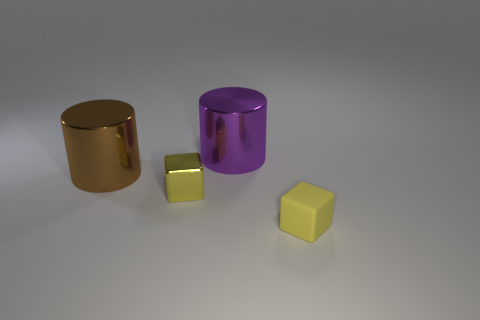How would you describe the texture of the objects in this image? The objects in the image appear to have a smooth, reflective texture. The surfaces are highly polished, allowing light to create soft highlights and gentle shadows which accentuates their three-dimensional forms. 